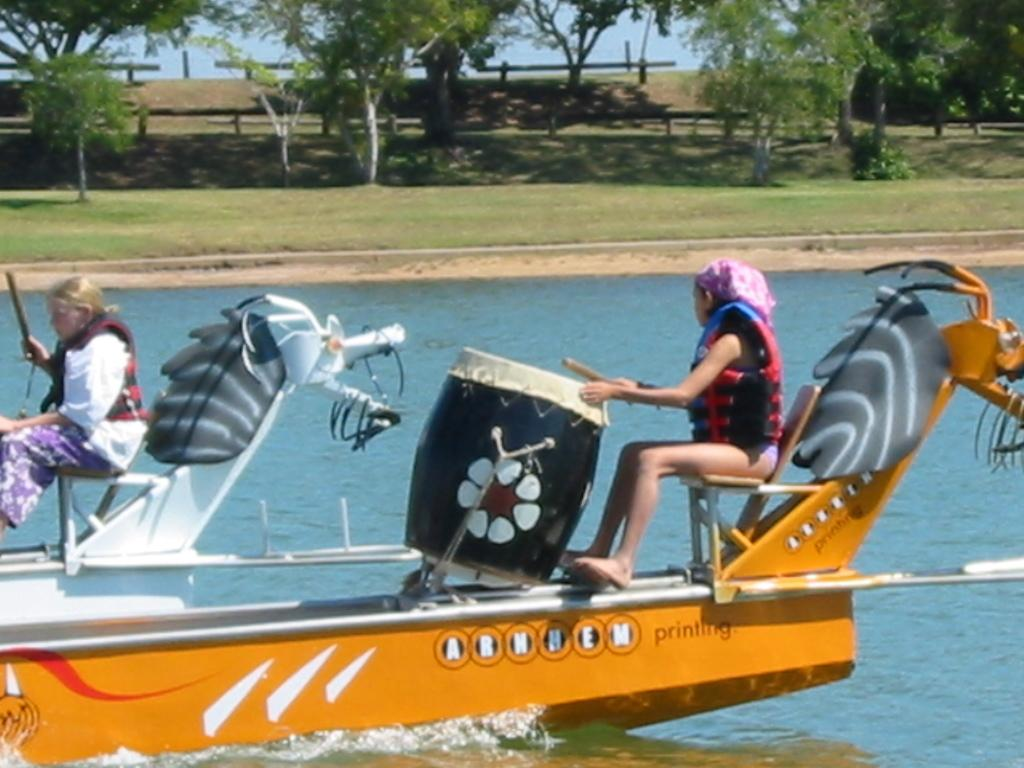How many people are on the boat in the image? There are two persons on the boat in the image. What is one of the persons doing on the boat? One of the persons is playing drums. What can be seen in the image besides the boat and the people? There is water visible in the image, and there are plants, grass, and trees in the background of the image. What type of cake is being served on the boat in the image? There is no cake present in the image; it features two persons on a boat, one of whom is playing drums. What type of lace can be seen on the boat in the image? There is no lace present on the boat in the image. 